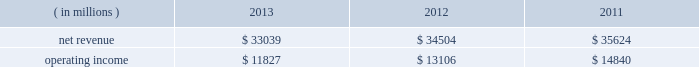Our overall gross margin percentage decreased to 59.8% ( 59.8 % ) in 2013 from 62.1% ( 62.1 % ) in 2012 .
The decrease in the gross margin percentage was primarily due to the gross margin percentage decrease in pccg .
We derived most of our overall gross margin dollars in 2013 and 2012 from the sale of platforms in the pccg and dcg operating segments .
Our net revenue for 2012 , which included 52 weeks , decreased by $ 658 million , or 1% ( 1 % ) , compared to 2011 , which included 53 weeks .
The pccg and dcg platform unit sales decreased 1% ( 1 % ) while average selling prices were unchanged .
Additionally , lower netbook platform unit sales and multi-comm average selling prices , primarily discrete modems , contributed to the decrease .
These decreases were partially offset by our mcafee operating segment , which we acquired in the q1 2011 .
Mcafee contributed $ 469 million of additional revenue in 2012 compared to 2011 .
Our overall gross margin dollars for 2012 decreased by $ 606 million , or 2% ( 2 % ) , compared to 2011 .
The decrease was due in large part to $ 494 million of excess capacity charges , as well as lower revenue from the pccg and dcg platform .
To a lesser extent , approximately $ 390 million of higher unit costs on the pccg and dcg platform as well as lower netbook and multi-comm revenue contributed to the decrease .
The decrease was partially offset by $ 643 million of lower factory start-up costs as we transition from our 22nm process technology to r&d of our next- generation 14nm process technology , as well as $ 422 million of charges recorded in 2011 to repair and replace materials and systems impacted by a design issue related to our intel ae 6 series express chipset family .
The decrease was also partially offset by the two additional months of results from our acquisition of mcafee , which occurred on february 28 , 2011 , contributing approximately $ 334 million of additional gross margin dollars in 2012 compared to 2011 .
The amortization of acquisition-related intangibles resulted in a $ 557 million reduction to our overall gross margin dollars in 2012 , compared to $ 482 million in 2011 , primarily due to acquisitions completed in q1 2011 .
Our overall gross margin percentage in 2012 was flat from 2011 as higher excess capacity charges and higher unit costs on the pccg and dcg platform were offset by lower factory start-up costs and no impact in 2012 for a design issue related to our intel 6 series express chipset family .
We derived a substantial majority of our overall gross margin dollars in 2012 and 2011 from the sale of platforms in the pccg and dcg operating segments .
Pc client group the revenue and operating income for the pccg operating segment for each period were as follows: .
Net revenue for the pccg operating segment decreased by $ 1.5 billion , or 4% ( 4 % ) , in 2013 compared to 2012 .
Pccg platform unit sales were down 3% ( 3 % ) primarily on softness in traditional pc demand during the first nine months of the year .
The decrease in revenue was driven by lower notebook and desktop platform unit sales which were down 4% ( 4 % ) and 2% ( 2 % ) , respectively .
Pccg platform average selling prices were flat , with 6% ( 6 % ) higher desktop platform average selling prices offset by 4% ( 4 % ) lower notebook platform average selling prices .
Operating income decreased by $ 1.3 billion , or 10% ( 10 % ) , in 2013 compared to 2012 , which was driven by $ 1.5 billion of lower gross margin , partially offset by $ 200 million of lower operating expenses .
The decrease in gross margin was driven by $ 1.5 billion of higher factory start-up costs primarily on our next-generation 14nm process technology as well as lower pccg platform revenue .
These decreases were partially offset by approximately $ 520 million of lower pccg platform unit costs , $ 260 million of lower excess capacity charges , and higher sell-through of previously non- qualified units .
Net revenue for the pccg operating segment decreased by $ 1.1 billion , or 3% ( 3 % ) , in 2012 compared to 2011 .
Pccg revenue was negatively impacted by the growth of tablets as these devices compete with pcs for consumer sales .
Platform average selling prices and unit sales decreased 2% ( 2 % ) and 1% ( 1 % ) , respectively .
The decrease was driven by 6% ( 6 % ) lower notebook platform average selling prices and 5% ( 5 % ) lower desktop platform unit sales .
These decreases were partially offset by a 4% ( 4 % ) increase in desktop platform average selling prices and a 2% ( 2 % ) increase in notebook platform unit sales .
Table of contents management 2019s discussion and analysis of financial condition and results of operations ( continued ) .
In 2013 what was the operating margin? 
Rationale: in 2013 the operating margin was 35.8%
Computations: (11827 / 33039)
Answer: 0.35797. Our overall gross margin percentage decreased to 59.8% ( 59.8 % ) in 2013 from 62.1% ( 62.1 % ) in 2012 .
The decrease in the gross margin percentage was primarily due to the gross margin percentage decrease in pccg .
We derived most of our overall gross margin dollars in 2013 and 2012 from the sale of platforms in the pccg and dcg operating segments .
Our net revenue for 2012 , which included 52 weeks , decreased by $ 658 million , or 1% ( 1 % ) , compared to 2011 , which included 53 weeks .
The pccg and dcg platform unit sales decreased 1% ( 1 % ) while average selling prices were unchanged .
Additionally , lower netbook platform unit sales and multi-comm average selling prices , primarily discrete modems , contributed to the decrease .
These decreases were partially offset by our mcafee operating segment , which we acquired in the q1 2011 .
Mcafee contributed $ 469 million of additional revenue in 2012 compared to 2011 .
Our overall gross margin dollars for 2012 decreased by $ 606 million , or 2% ( 2 % ) , compared to 2011 .
The decrease was due in large part to $ 494 million of excess capacity charges , as well as lower revenue from the pccg and dcg platform .
To a lesser extent , approximately $ 390 million of higher unit costs on the pccg and dcg platform as well as lower netbook and multi-comm revenue contributed to the decrease .
The decrease was partially offset by $ 643 million of lower factory start-up costs as we transition from our 22nm process technology to r&d of our next- generation 14nm process technology , as well as $ 422 million of charges recorded in 2011 to repair and replace materials and systems impacted by a design issue related to our intel ae 6 series express chipset family .
The decrease was also partially offset by the two additional months of results from our acquisition of mcafee , which occurred on february 28 , 2011 , contributing approximately $ 334 million of additional gross margin dollars in 2012 compared to 2011 .
The amortization of acquisition-related intangibles resulted in a $ 557 million reduction to our overall gross margin dollars in 2012 , compared to $ 482 million in 2011 , primarily due to acquisitions completed in q1 2011 .
Our overall gross margin percentage in 2012 was flat from 2011 as higher excess capacity charges and higher unit costs on the pccg and dcg platform were offset by lower factory start-up costs and no impact in 2012 for a design issue related to our intel 6 series express chipset family .
We derived a substantial majority of our overall gross margin dollars in 2012 and 2011 from the sale of platforms in the pccg and dcg operating segments .
Pc client group the revenue and operating income for the pccg operating segment for each period were as follows: .
Net revenue for the pccg operating segment decreased by $ 1.5 billion , or 4% ( 4 % ) , in 2013 compared to 2012 .
Pccg platform unit sales were down 3% ( 3 % ) primarily on softness in traditional pc demand during the first nine months of the year .
The decrease in revenue was driven by lower notebook and desktop platform unit sales which were down 4% ( 4 % ) and 2% ( 2 % ) , respectively .
Pccg platform average selling prices were flat , with 6% ( 6 % ) higher desktop platform average selling prices offset by 4% ( 4 % ) lower notebook platform average selling prices .
Operating income decreased by $ 1.3 billion , or 10% ( 10 % ) , in 2013 compared to 2012 , which was driven by $ 1.5 billion of lower gross margin , partially offset by $ 200 million of lower operating expenses .
The decrease in gross margin was driven by $ 1.5 billion of higher factory start-up costs primarily on our next-generation 14nm process technology as well as lower pccg platform revenue .
These decreases were partially offset by approximately $ 520 million of lower pccg platform unit costs , $ 260 million of lower excess capacity charges , and higher sell-through of previously non- qualified units .
Net revenue for the pccg operating segment decreased by $ 1.1 billion , or 3% ( 3 % ) , in 2012 compared to 2011 .
Pccg revenue was negatively impacted by the growth of tablets as these devices compete with pcs for consumer sales .
Platform average selling prices and unit sales decreased 2% ( 2 % ) and 1% ( 1 % ) , respectively .
The decrease was driven by 6% ( 6 % ) lower notebook platform average selling prices and 5% ( 5 % ) lower desktop platform unit sales .
These decreases were partially offset by a 4% ( 4 % ) increase in desktop platform average selling prices and a 2% ( 2 % ) increase in notebook platform unit sales .
Table of contents management 2019s discussion and analysis of financial condition and results of operations ( continued ) .
What was the operating margin for the pc client group in 2012? 
Computations: (13106 / 34504)
Answer: 0.37984. 